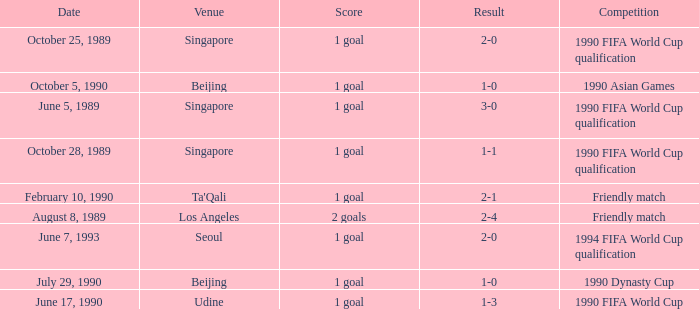Could you parse the entire table? {'header': ['Date', 'Venue', 'Score', 'Result', 'Competition'], 'rows': [['October 25, 1989', 'Singapore', '1 goal', '2-0', '1990 FIFA World Cup qualification'], ['October 5, 1990', 'Beijing', '1 goal', '1-0', '1990 Asian Games'], ['June 5, 1989', 'Singapore', '1 goal', '3-0', '1990 FIFA World Cup qualification'], ['October 28, 1989', 'Singapore', '1 goal', '1-1', '1990 FIFA World Cup qualification'], ['February 10, 1990', "Ta'Qali", '1 goal', '2-1', 'Friendly match'], ['August 8, 1989', 'Los Angeles', '2 goals', '2-4', 'Friendly match'], ['June 7, 1993', 'Seoul', '1 goal', '2-0', '1994 FIFA World Cup qualification'], ['July 29, 1990', 'Beijing', '1 goal', '1-0', '1990 Dynasty Cup'], ['June 17, 1990', 'Udine', '1 goal', '1-3', '1990 FIFA World Cup']]} What was the score of the match with a 3-0 result? 1 goal. 